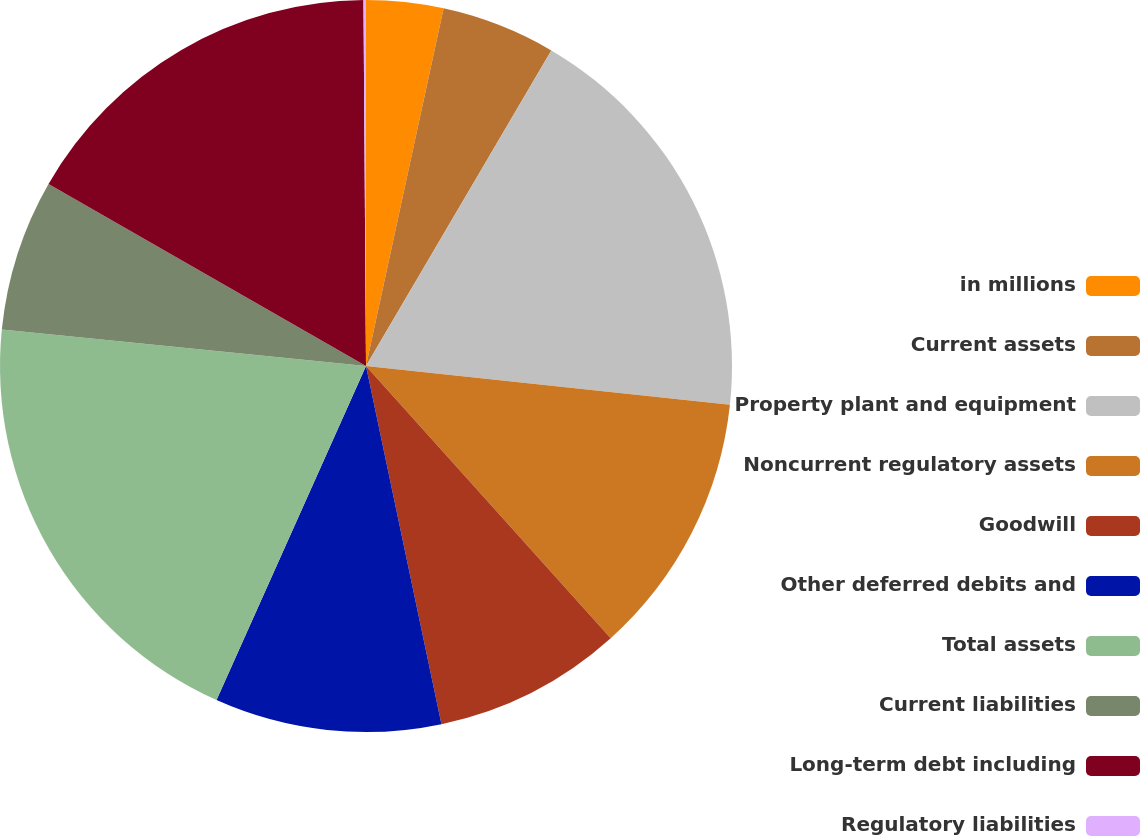<chart> <loc_0><loc_0><loc_500><loc_500><pie_chart><fcel>in millions<fcel>Current assets<fcel>Property plant and equipment<fcel>Noncurrent regulatory assets<fcel>Goodwill<fcel>Other deferred debits and<fcel>Total assets<fcel>Current liabilities<fcel>Long-term debt including<fcel>Regulatory liabilities<nl><fcel>3.4%<fcel>5.05%<fcel>18.24%<fcel>11.65%<fcel>8.35%<fcel>10.0%<fcel>19.89%<fcel>6.7%<fcel>16.6%<fcel>0.11%<nl></chart> 